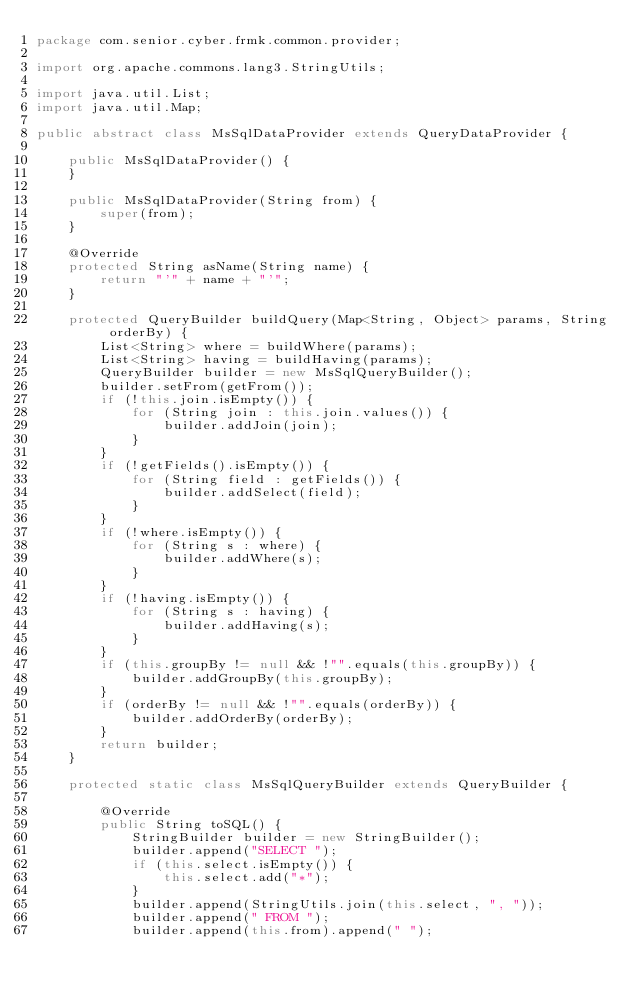Convert code to text. <code><loc_0><loc_0><loc_500><loc_500><_Java_>package com.senior.cyber.frmk.common.provider;

import org.apache.commons.lang3.StringUtils;

import java.util.List;
import java.util.Map;

public abstract class MsSqlDataProvider extends QueryDataProvider {

    public MsSqlDataProvider() {
    }

    public MsSqlDataProvider(String from) {
        super(from);
    }

    @Override
    protected String asName(String name) {
        return "'" + name + "'";
    }

    protected QueryBuilder buildQuery(Map<String, Object> params, String orderBy) {
        List<String> where = buildWhere(params);
        List<String> having = buildHaving(params);
        QueryBuilder builder = new MsSqlQueryBuilder();
        builder.setFrom(getFrom());
        if (!this.join.isEmpty()) {
            for (String join : this.join.values()) {
                builder.addJoin(join);
            }
        }
        if (!getFields().isEmpty()) {
            for (String field : getFields()) {
                builder.addSelect(field);
            }
        }
        if (!where.isEmpty()) {
            for (String s : where) {
                builder.addWhere(s);
            }
        }
        if (!having.isEmpty()) {
            for (String s : having) {
                builder.addHaving(s);
            }
        }
        if (this.groupBy != null && !"".equals(this.groupBy)) {
            builder.addGroupBy(this.groupBy);
        }
        if (orderBy != null && !"".equals(orderBy)) {
            builder.addOrderBy(orderBy);
        }
        return builder;
    }

    protected static class MsSqlQueryBuilder extends QueryBuilder {

        @Override
        public String toSQL() {
            StringBuilder builder = new StringBuilder();
            builder.append("SELECT ");
            if (this.select.isEmpty()) {
                this.select.add("*");
            }
            builder.append(StringUtils.join(this.select, ", "));
            builder.append(" FROM ");
            builder.append(this.from).append(" ");</code> 